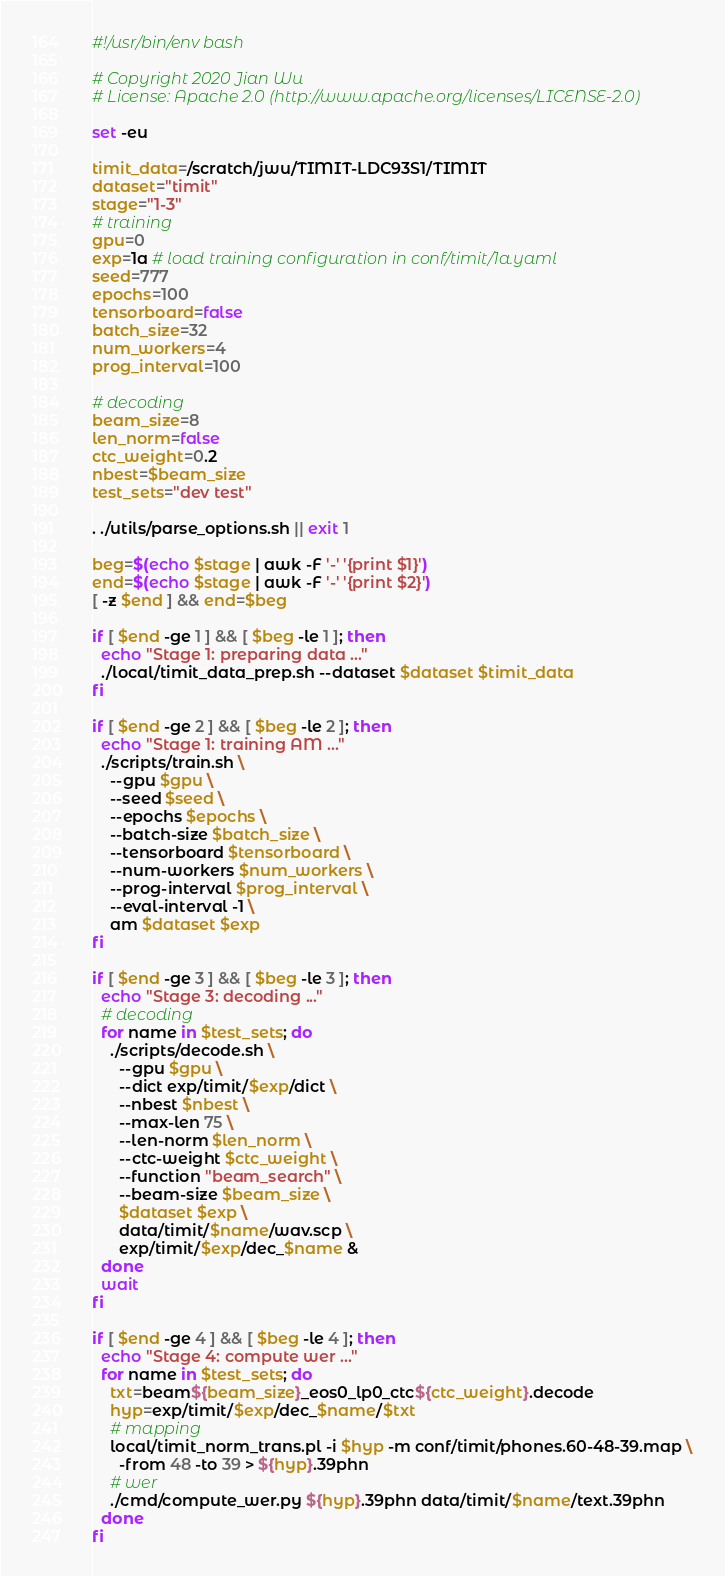Convert code to text. <code><loc_0><loc_0><loc_500><loc_500><_Bash_>#!/usr/bin/env bash

# Copyright 2020 Jian Wu
# License: Apache 2.0 (http://www.apache.org/licenses/LICENSE-2.0)

set -eu

timit_data=/scratch/jwu/TIMIT-LDC93S1/TIMIT
dataset="timit"
stage="1-3"
# training
gpu=0
exp=1a # load training configuration in conf/timit/1a.yaml
seed=777
epochs=100
tensorboard=false
batch_size=32
num_workers=4
prog_interval=100

# decoding
beam_size=8
len_norm=false
ctc_weight=0.2
nbest=$beam_size
test_sets="dev test"

. ./utils/parse_options.sh || exit 1

beg=$(echo $stage | awk -F '-' '{print $1}')
end=$(echo $stage | awk -F '-' '{print $2}')
[ -z $end ] && end=$beg

if [ $end -ge 1 ] && [ $beg -le 1 ]; then
  echo "Stage 1: preparing data ..."
  ./local/timit_data_prep.sh --dataset $dataset $timit_data
fi

if [ $end -ge 2 ] && [ $beg -le 2 ]; then
  echo "Stage 1: training AM ..."
  ./scripts/train.sh \
    --gpu $gpu \
    --seed $seed \
    --epochs $epochs \
    --batch-size $batch_size \
    --tensorboard $tensorboard \
    --num-workers $num_workers \
    --prog-interval $prog_interval \
    --eval-interval -1 \
    am $dataset $exp
fi

if [ $end -ge 3 ] && [ $beg -le 3 ]; then
  echo "Stage 3: decoding ..."
  # decoding
  for name in $test_sets; do
    ./scripts/decode.sh \
      --gpu $gpu \
      --dict exp/timit/$exp/dict \
      --nbest $nbest \
      --max-len 75 \
      --len-norm $len_norm \
      --ctc-weight $ctc_weight \
      --function "beam_search" \
      --beam-size $beam_size \
      $dataset $exp \
      data/timit/$name/wav.scp \
      exp/timit/$exp/dec_$name &
  done
  wait
fi

if [ $end -ge 4 ] && [ $beg -le 4 ]; then
  echo "Stage 4: compute wer ..."
  for name in $test_sets; do
    txt=beam${beam_size}_eos0_lp0_ctc${ctc_weight}.decode
    hyp=exp/timit/$exp/dec_$name/$txt
    # mapping
    local/timit_norm_trans.pl -i $hyp -m conf/timit/phones.60-48-39.map \
      -from 48 -to 39 > ${hyp}.39phn
    # wer
    ./cmd/compute_wer.py ${hyp}.39phn data/timit/$name/text.39phn
  done
fi
</code> 